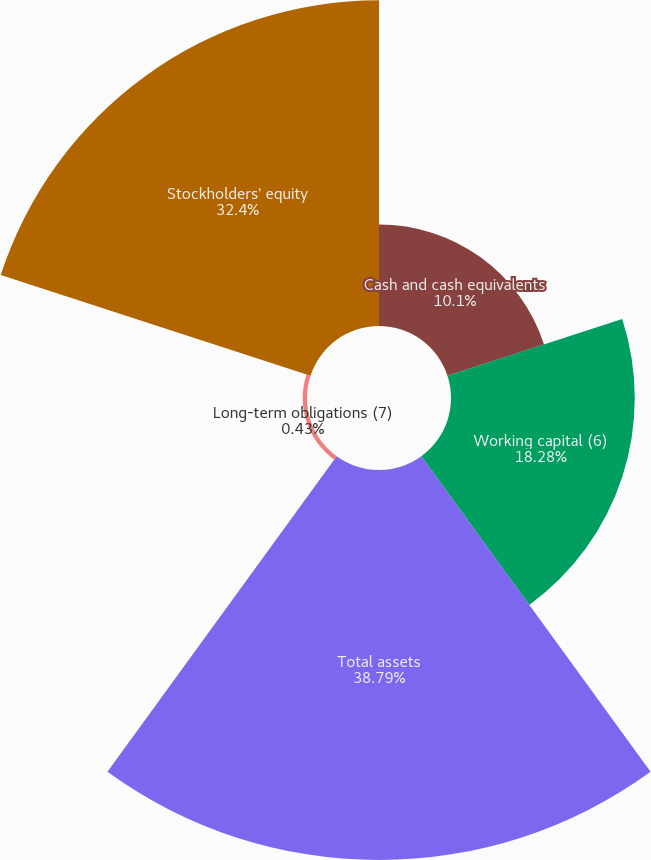Convert chart to OTSL. <chart><loc_0><loc_0><loc_500><loc_500><pie_chart><fcel>Cash and cash equivalents<fcel>Working capital (6)<fcel>Total assets<fcel>Long-term obligations (7)<fcel>Stockholders' equity<nl><fcel>10.1%<fcel>18.28%<fcel>38.8%<fcel>0.43%<fcel>32.41%<nl></chart> 